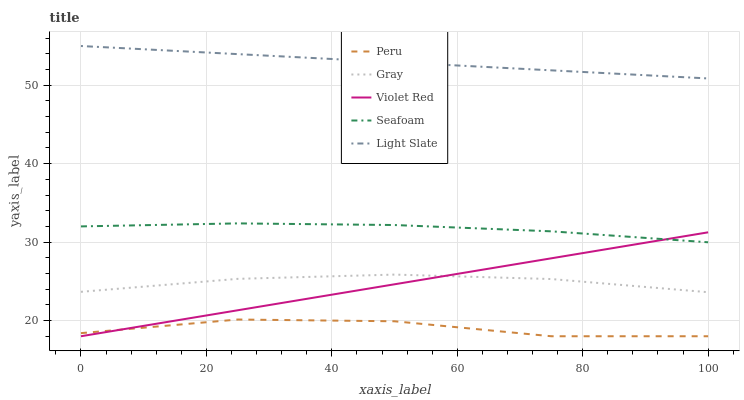Does Gray have the minimum area under the curve?
Answer yes or no. No. Does Gray have the maximum area under the curve?
Answer yes or no. No. Is Gray the smoothest?
Answer yes or no. No. Is Gray the roughest?
Answer yes or no. No. Does Gray have the lowest value?
Answer yes or no. No. Does Gray have the highest value?
Answer yes or no. No. Is Peru less than Gray?
Answer yes or no. Yes. Is Seafoam greater than Gray?
Answer yes or no. Yes. Does Peru intersect Gray?
Answer yes or no. No. 